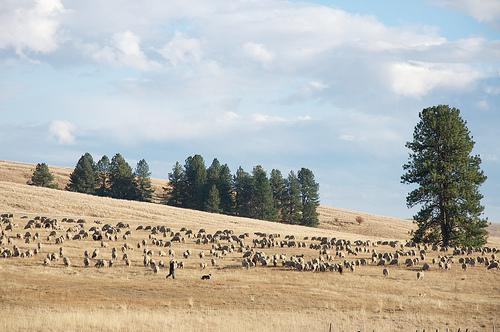Question: what are the white objects in the sky?
Choices:
A. Kites.
B. Clouds.
C. AIrplanes.
D. Birds.
Answer with the letter. Answer: B Question: where are the animals standing?
Choices:
A. Ocean.
B. Field.
C. Sand.
D. Water.
Answer with the letter. Answer: B Question: what color is the field?
Choices:
A. White.
B. Tan.
C. Gold.
D. Amber.
Answer with the letter. Answer: B Question: where is this taking place?
Choices:
A. In a ZOO.
B. In a circus.
C. In a park.
D. In a field.
Answer with the letter. Answer: D 